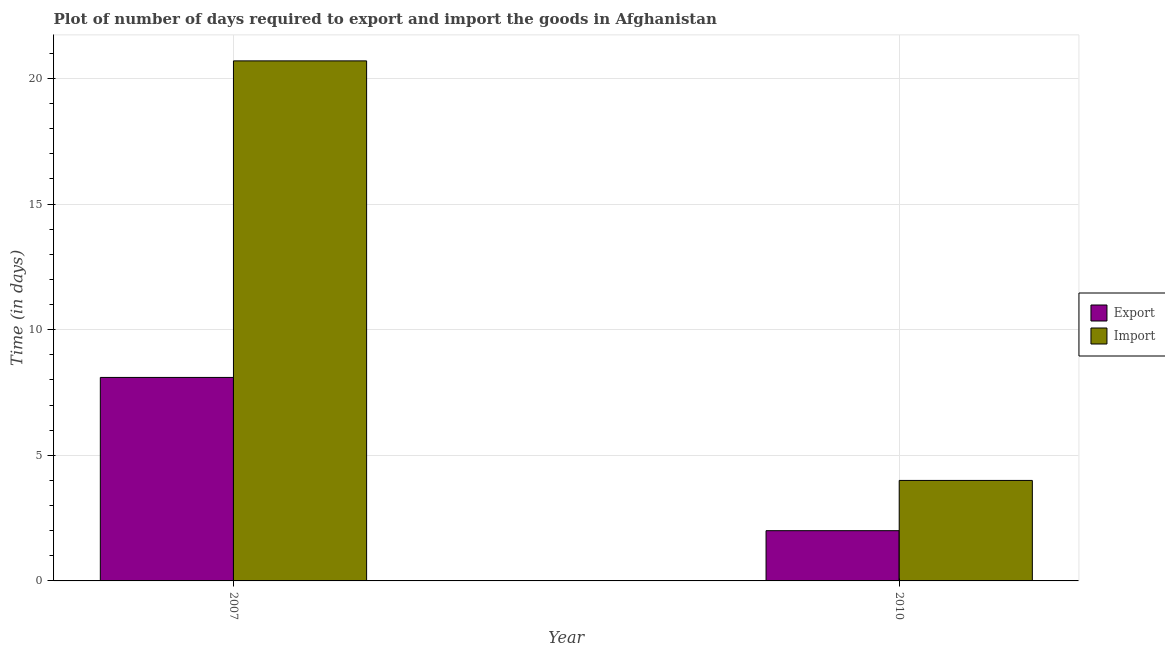How many different coloured bars are there?
Offer a terse response. 2. Are the number of bars per tick equal to the number of legend labels?
Offer a very short reply. Yes. Are the number of bars on each tick of the X-axis equal?
Keep it short and to the point. Yes. How many bars are there on the 1st tick from the right?
Make the answer very short. 2. In how many cases, is the number of bars for a given year not equal to the number of legend labels?
Offer a terse response. 0. Across all years, what is the maximum time required to import?
Your response must be concise. 20.7. Across all years, what is the minimum time required to export?
Offer a very short reply. 2. In which year was the time required to import maximum?
Your answer should be compact. 2007. In which year was the time required to export minimum?
Offer a terse response. 2010. What is the total time required to import in the graph?
Your answer should be compact. 24.7. What is the difference between the time required to import in 2007 and that in 2010?
Offer a terse response. 16.7. What is the difference between the time required to import in 2010 and the time required to export in 2007?
Your response must be concise. -16.7. What is the average time required to export per year?
Make the answer very short. 5.05. In the year 2007, what is the difference between the time required to export and time required to import?
Your answer should be very brief. 0. What is the ratio of the time required to export in 2007 to that in 2010?
Make the answer very short. 4.05. In how many years, is the time required to export greater than the average time required to export taken over all years?
Provide a short and direct response. 1. What does the 1st bar from the left in 2007 represents?
Your answer should be compact. Export. What does the 1st bar from the right in 2007 represents?
Offer a very short reply. Import. How many bars are there?
Your answer should be very brief. 4. Are all the bars in the graph horizontal?
Give a very brief answer. No. How many years are there in the graph?
Keep it short and to the point. 2. What is the difference between two consecutive major ticks on the Y-axis?
Ensure brevity in your answer.  5. Does the graph contain grids?
Make the answer very short. Yes. What is the title of the graph?
Offer a very short reply. Plot of number of days required to export and import the goods in Afghanistan. Does "Canada" appear as one of the legend labels in the graph?
Make the answer very short. No. What is the label or title of the Y-axis?
Your answer should be compact. Time (in days). What is the Time (in days) of Import in 2007?
Ensure brevity in your answer.  20.7. What is the Time (in days) of Import in 2010?
Give a very brief answer. 4. Across all years, what is the maximum Time (in days) in Export?
Ensure brevity in your answer.  8.1. Across all years, what is the maximum Time (in days) of Import?
Your answer should be very brief. 20.7. What is the total Time (in days) in Export in the graph?
Ensure brevity in your answer.  10.1. What is the total Time (in days) in Import in the graph?
Your answer should be very brief. 24.7. What is the difference between the Time (in days) of Export in 2007 and that in 2010?
Give a very brief answer. 6.1. What is the average Time (in days) of Export per year?
Provide a short and direct response. 5.05. What is the average Time (in days) in Import per year?
Offer a very short reply. 12.35. In the year 2007, what is the difference between the Time (in days) of Export and Time (in days) of Import?
Offer a very short reply. -12.6. What is the ratio of the Time (in days) in Export in 2007 to that in 2010?
Give a very brief answer. 4.05. What is the ratio of the Time (in days) of Import in 2007 to that in 2010?
Provide a short and direct response. 5.17. 